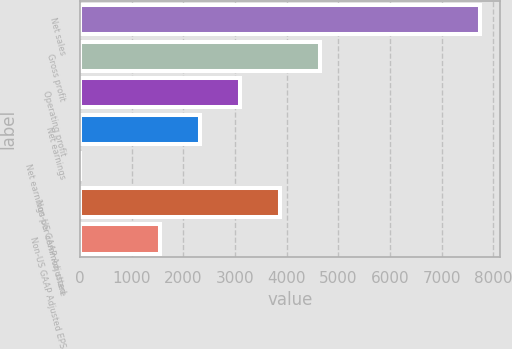Convert chart. <chart><loc_0><loc_0><loc_500><loc_500><bar_chart><fcel>Net sales<fcel>Gross profit<fcel>Operating profit<fcel>Net earnings<fcel>Net earnings per common share<fcel>Non-US GAAP Adjusted<fcel>Non-US GAAP Adjusted EPS<nl><fcel>7750.5<fcel>4650.78<fcel>3100.92<fcel>2325.99<fcel>1.2<fcel>3875.85<fcel>1551.06<nl></chart> 